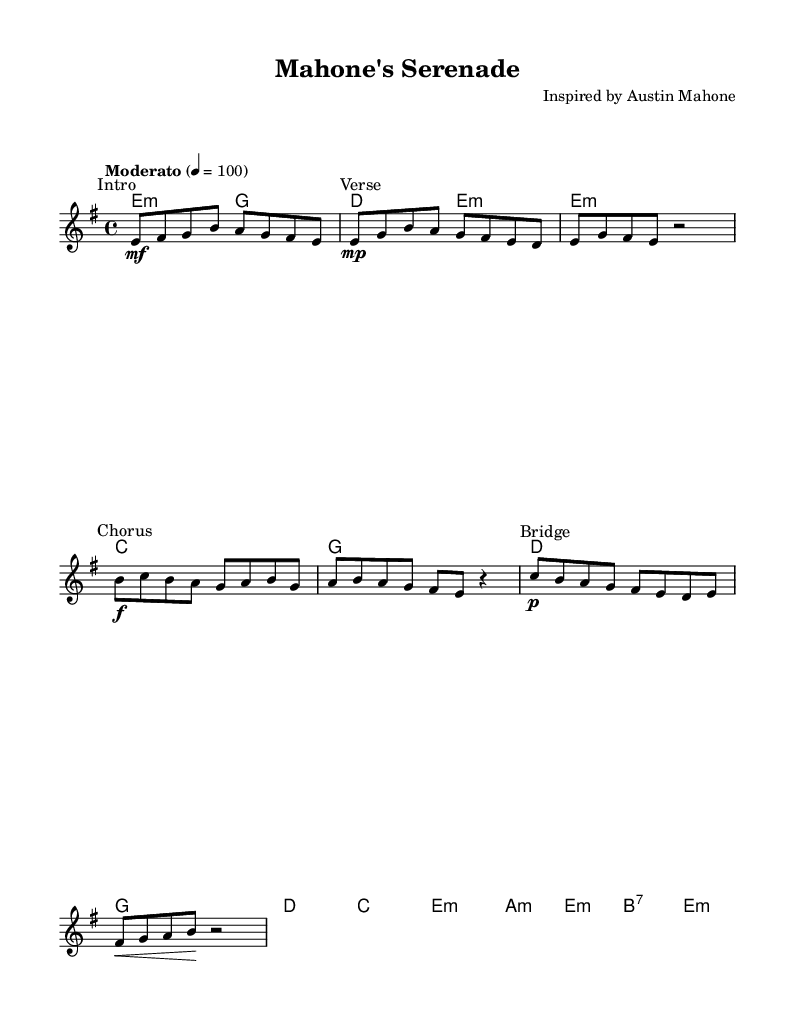What is the key signature of this music? The key signature is E minor, which has one sharp (F#). In the global music setting, it indicates that the piece is centered around E minor tonality.
Answer: E minor What is the time signature of this piece? The time signature is 4/4, which is indicated at the start of the global settings. This means there are four beats in each measure, and each quarter note receives one beat.
Answer: 4/4 What is the tempo marking of the score? The tempo marking is "Moderato" with a metronome indication of 4 = 100, which signifies a moderate pace, around 100 beats per minute.
Answer: Moderato How many sections are indicated in the piece? There are four distinct sections indicated: Intro, Verse, Chorus, and Bridge. These sections help organize the composition and provide structure throughout the piece.
Answer: Four What harmony chord is used at the beginning of the piece? The first harmony chord indicated is E minor (e2:m), which aligns with the key signature and provides the tonic chord for the piece. This sets the foundational sound for the upcoming melodies.
Answer: E minor Which dynamic marking is indicated in the Chorus? The dynamic marking indicated in the Chorus section is "f," which stands for fortissimo, meaning to play very loudly. This marking emphasizes the build and emotional intensity during this part of the piece.
Answer: f What is the final chord in the score? The final chord in the score is E minor (e:m), which serves as the tonic and final resolution of the piece, bringing closure to the musical narrative.
Answer: E minor 